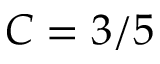Convert formula to latex. <formula><loc_0><loc_0><loc_500><loc_500>C = 3 / 5</formula> 